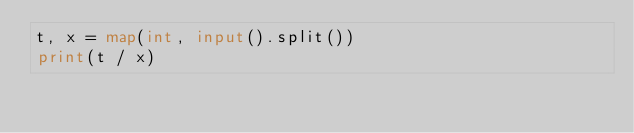Convert code to text. <code><loc_0><loc_0><loc_500><loc_500><_Python_>t, x = map(int, input().split())
print(t / x)
</code> 